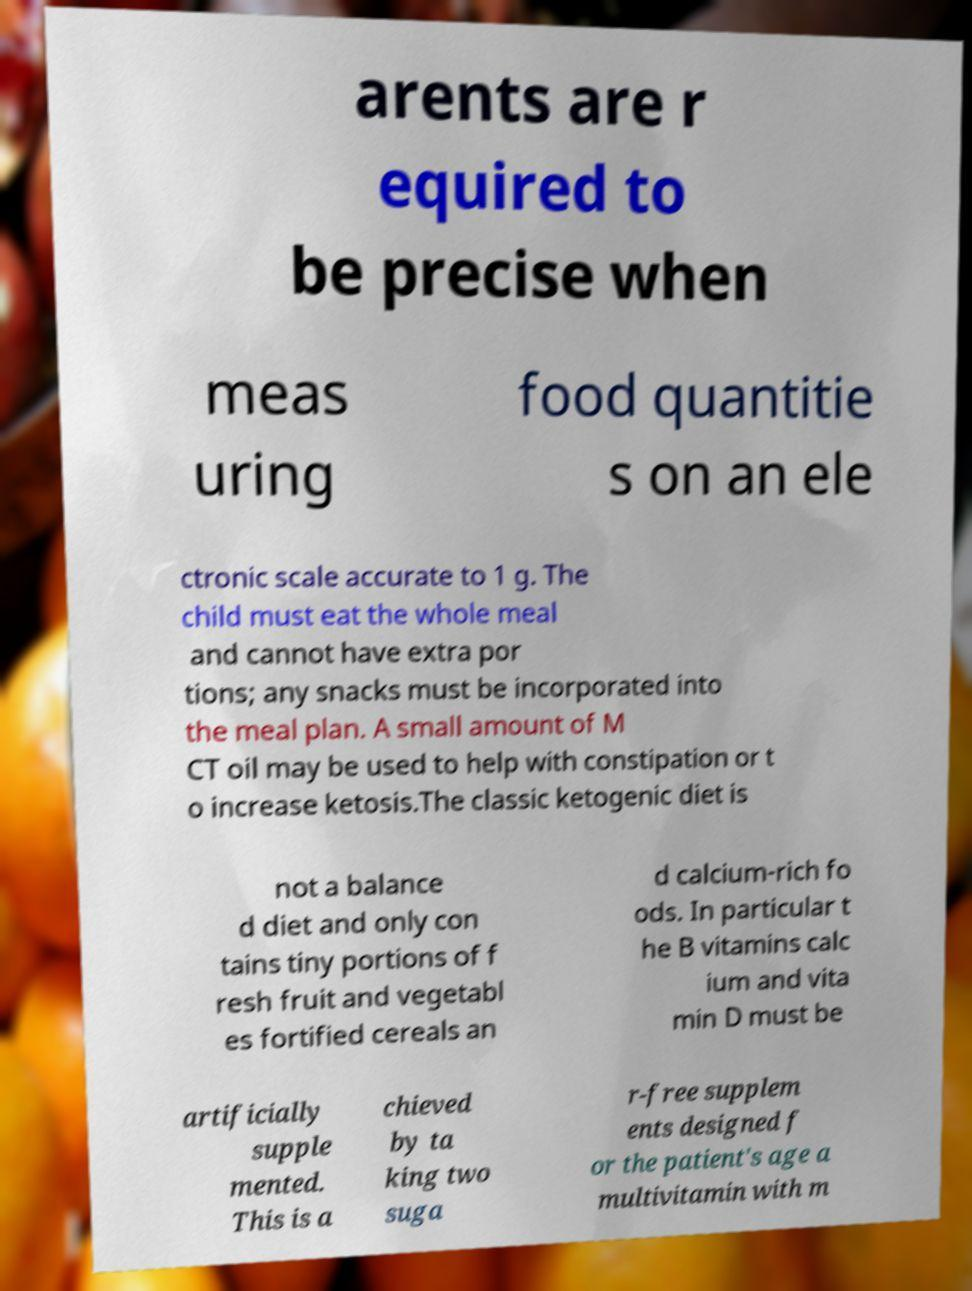What messages or text are displayed in this image? I need them in a readable, typed format. arents are r equired to be precise when meas uring food quantitie s on an ele ctronic scale accurate to 1 g. The child must eat the whole meal and cannot have extra por tions; any snacks must be incorporated into the meal plan. A small amount of M CT oil may be used to help with constipation or t o increase ketosis.The classic ketogenic diet is not a balance d diet and only con tains tiny portions of f resh fruit and vegetabl es fortified cereals an d calcium-rich fo ods. In particular t he B vitamins calc ium and vita min D must be artificially supple mented. This is a chieved by ta king two suga r-free supplem ents designed f or the patient's age a multivitamin with m 